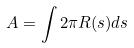<formula> <loc_0><loc_0><loc_500><loc_500>A = \int 2 \pi R ( s ) d s</formula> 